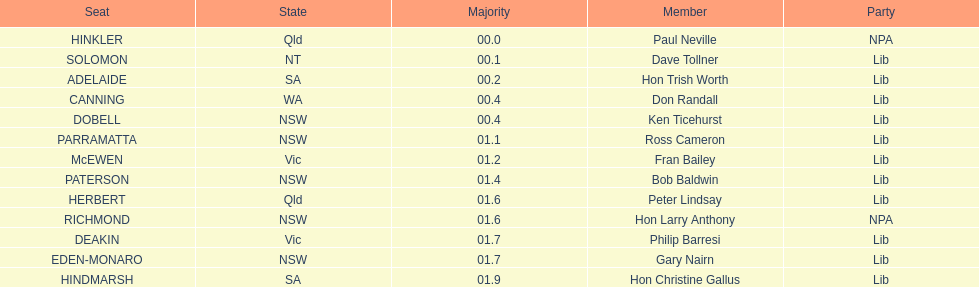How many members in total? 13. 